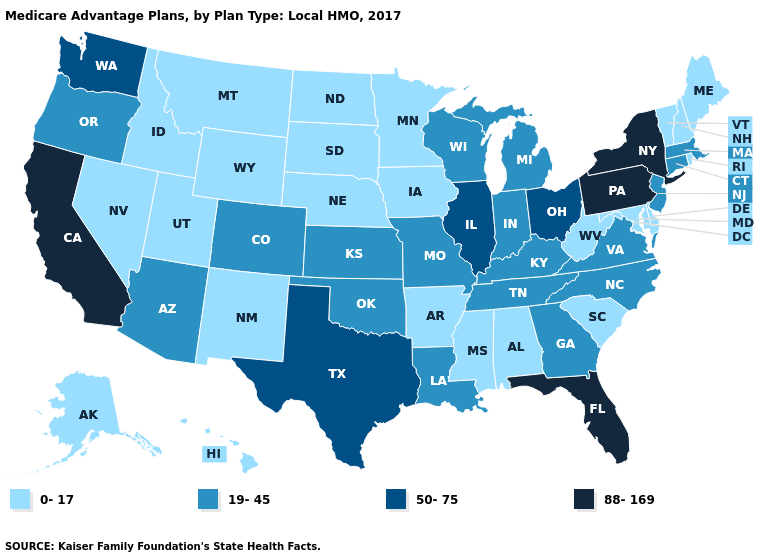What is the lowest value in the USA?
Write a very short answer. 0-17. What is the value of Delaware?
Concise answer only. 0-17. Does the map have missing data?
Give a very brief answer. No. Which states have the lowest value in the USA?
Short answer required. Alaska, Alabama, Arkansas, Delaware, Hawaii, Iowa, Idaho, Maryland, Maine, Minnesota, Mississippi, Montana, North Dakota, Nebraska, New Hampshire, New Mexico, Nevada, Rhode Island, South Carolina, South Dakota, Utah, Vermont, West Virginia, Wyoming. Does Alabama have a lower value than Hawaii?
Answer briefly. No. Does Hawaii have the highest value in the USA?
Give a very brief answer. No. Name the states that have a value in the range 0-17?
Answer briefly. Alaska, Alabama, Arkansas, Delaware, Hawaii, Iowa, Idaho, Maryland, Maine, Minnesota, Mississippi, Montana, North Dakota, Nebraska, New Hampshire, New Mexico, Nevada, Rhode Island, South Carolina, South Dakota, Utah, Vermont, West Virginia, Wyoming. How many symbols are there in the legend?
Write a very short answer. 4. What is the value of Nevada?
Give a very brief answer. 0-17. Does Texas have the same value as Ohio?
Write a very short answer. Yes. Name the states that have a value in the range 19-45?
Quick response, please. Arizona, Colorado, Connecticut, Georgia, Indiana, Kansas, Kentucky, Louisiana, Massachusetts, Michigan, Missouri, North Carolina, New Jersey, Oklahoma, Oregon, Tennessee, Virginia, Wisconsin. Does North Dakota have a higher value than Idaho?
Give a very brief answer. No. Name the states that have a value in the range 88-169?
Give a very brief answer. California, Florida, New York, Pennsylvania. What is the lowest value in the Northeast?
Write a very short answer. 0-17. 